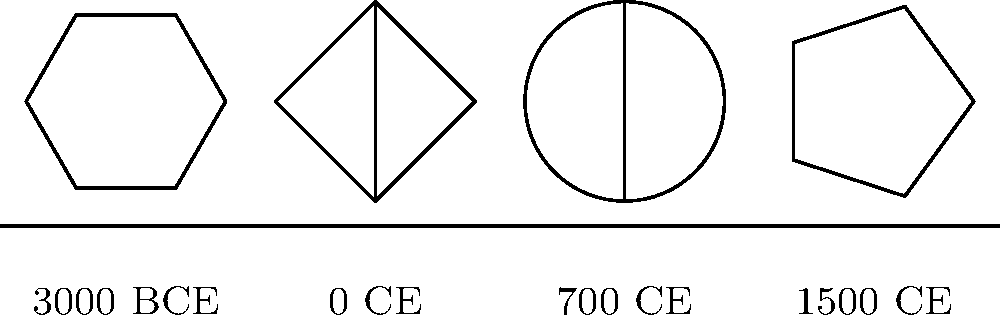Based on the timeline of simplified religious symbols shown, which symbol is most likely associated with the rise of Islam? To answer this question, we need to analyze the symbols and their corresponding time periods:

1. 3000 BCE: A hexagonal symbol, likely representing early polytheistic religions.
2. 0 CE: A cross symbol, clearly associated with the rise of Christianity.
3. 700 CE: A circle with a vertical line, which is the focus of our question.
4. 1500 CE: A five-pointed star, possibly representing various religious or secular symbols.

The key to answering this question lies in understanding the historical context:

1. Islam was founded in the 7th century CE (around 610 CE) by the Prophet Muhammad.
2. The symbol at 700 CE on the timeline closely resembles a simplified version of the crescent moon, which is a widely recognized symbol of Islam.
3. While the crescent moon was not originally an Islamic symbol, it became associated with Islam during the expansion of the Ottoman Empire (14th-20th centuries).
4. The timing of this symbol (700 CE) aligns closely with the early spread of Islam following Muhammad's death in 632 CE.

Therefore, based on the historical context and the timing shown in the timeline, the symbol at 700 CE is most likely associated with the rise of Islam.
Answer: The circle with a vertical line at 700 CE 